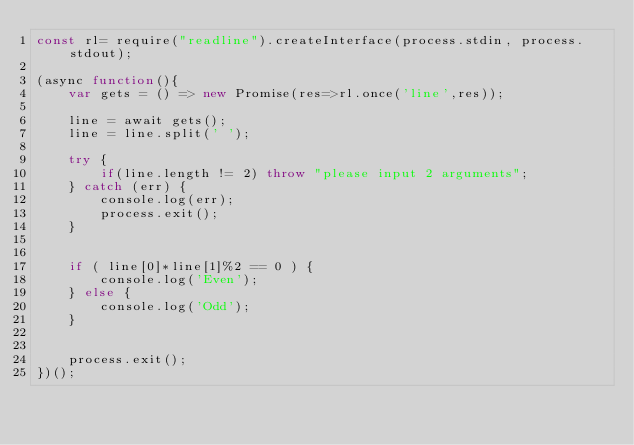<code> <loc_0><loc_0><loc_500><loc_500><_JavaScript_>const rl= require("readline").createInterface(process.stdin, process.stdout);

(async function(){
    var gets = () => new Promise(res=>rl.once('line',res));

    line = await gets();
    line = line.split(' ');

    try {
        if(line.length != 2) throw "please input 2 arguments";
    } catch (err) {
        console.log(err);
        process.exit();
    }


    if ( line[0]*line[1]%2 == 0 ) {
        console.log('Even');
    } else {
        console.log('Odd');
    }


    process.exit();
})();</code> 